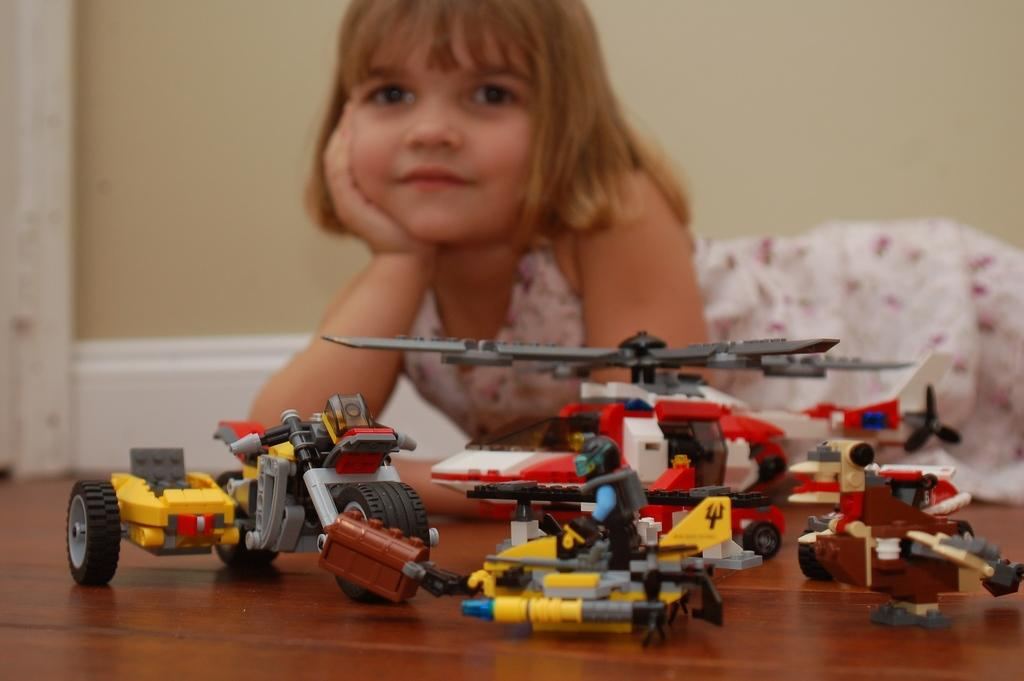Who is the main subject in the image? There is a girl in the image. What is the girl's position in the image? The girl is on the floor. What can be seen in front of the girl? There are toys in front of the girl. What is visible behind the girl? There is a wall behind the girl. What type of wheel is the girl using to turn the substance in the image? There is no wheel or substance present in the image; it features a girl on the floor with toys in front of her. 